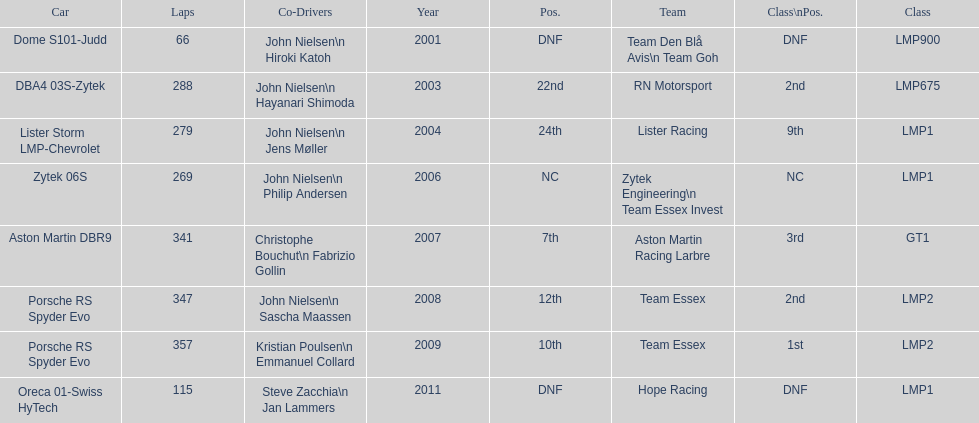How many times was the final position above 20? 2. Would you be able to parse every entry in this table? {'header': ['Car', 'Laps', 'Co-Drivers', 'Year', 'Pos.', 'Team', 'Class\\nPos.', 'Class'], 'rows': [['Dome S101-Judd', '66', 'John Nielsen\\n Hiroki Katoh', '2001', 'DNF', 'Team Den Blå Avis\\n Team Goh', 'DNF', 'LMP900'], ['DBA4 03S-Zytek', '288', 'John Nielsen\\n Hayanari Shimoda', '2003', '22nd', 'RN Motorsport', '2nd', 'LMP675'], ['Lister Storm LMP-Chevrolet', '279', 'John Nielsen\\n Jens Møller', '2004', '24th', 'Lister Racing', '9th', 'LMP1'], ['Zytek 06S', '269', 'John Nielsen\\n Philip Andersen', '2006', 'NC', 'Zytek Engineering\\n Team Essex Invest', 'NC', 'LMP1'], ['Aston Martin DBR9', '341', 'Christophe Bouchut\\n Fabrizio Gollin', '2007', '7th', 'Aston Martin Racing Larbre', '3rd', 'GT1'], ['Porsche RS Spyder Evo', '347', 'John Nielsen\\n Sascha Maassen', '2008', '12th', 'Team Essex', '2nd', 'LMP2'], ['Porsche RS Spyder Evo', '357', 'Kristian Poulsen\\n Emmanuel Collard', '2009', '10th', 'Team Essex', '1st', 'LMP2'], ['Oreca 01-Swiss HyTech', '115', 'Steve Zacchia\\n Jan Lammers', '2011', 'DNF', 'Hope Racing', 'DNF', 'LMP1']]} 